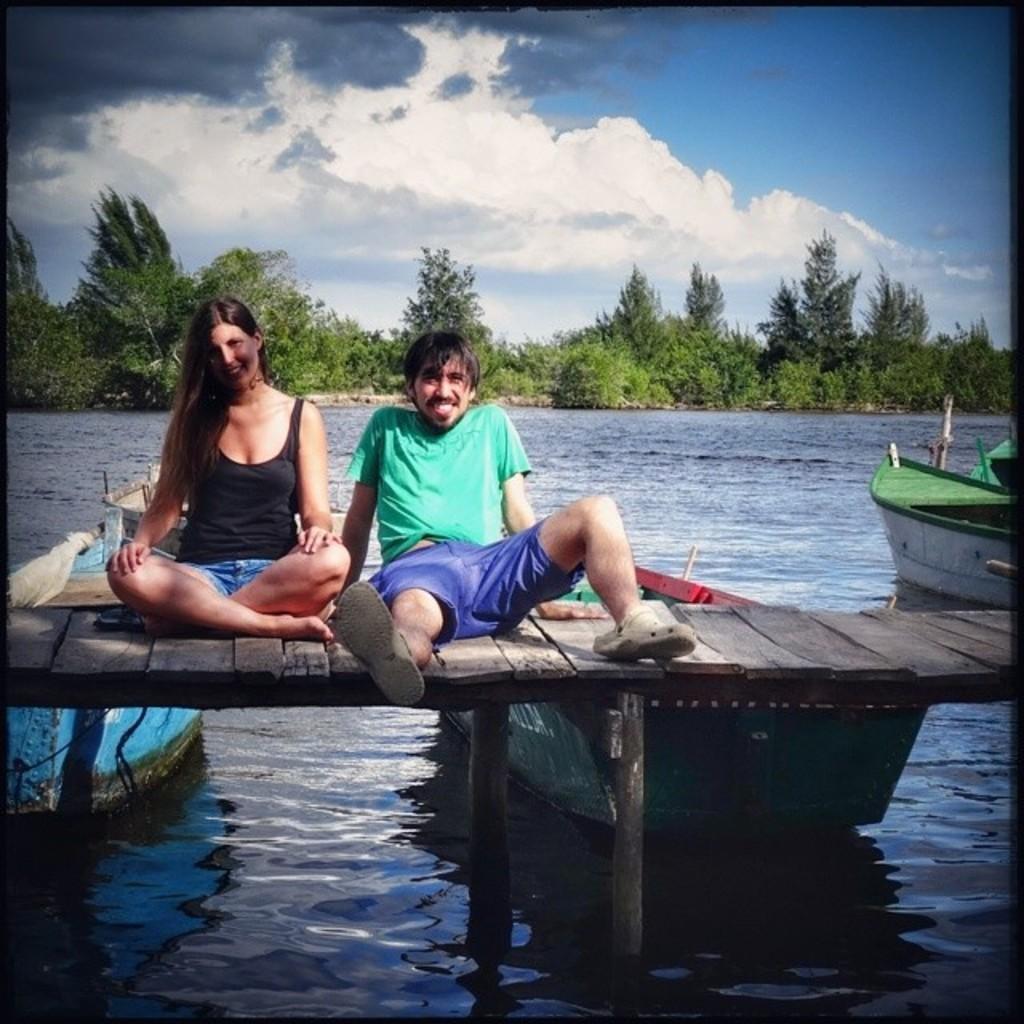Can you describe this image briefly? In the center of the image we can see two persons are sitting on a bridge. In the background of the image we can see some boats are present on the water. In the middle of the image we can see the trees. At the top of the image we can see the clouds are present in the sky. 